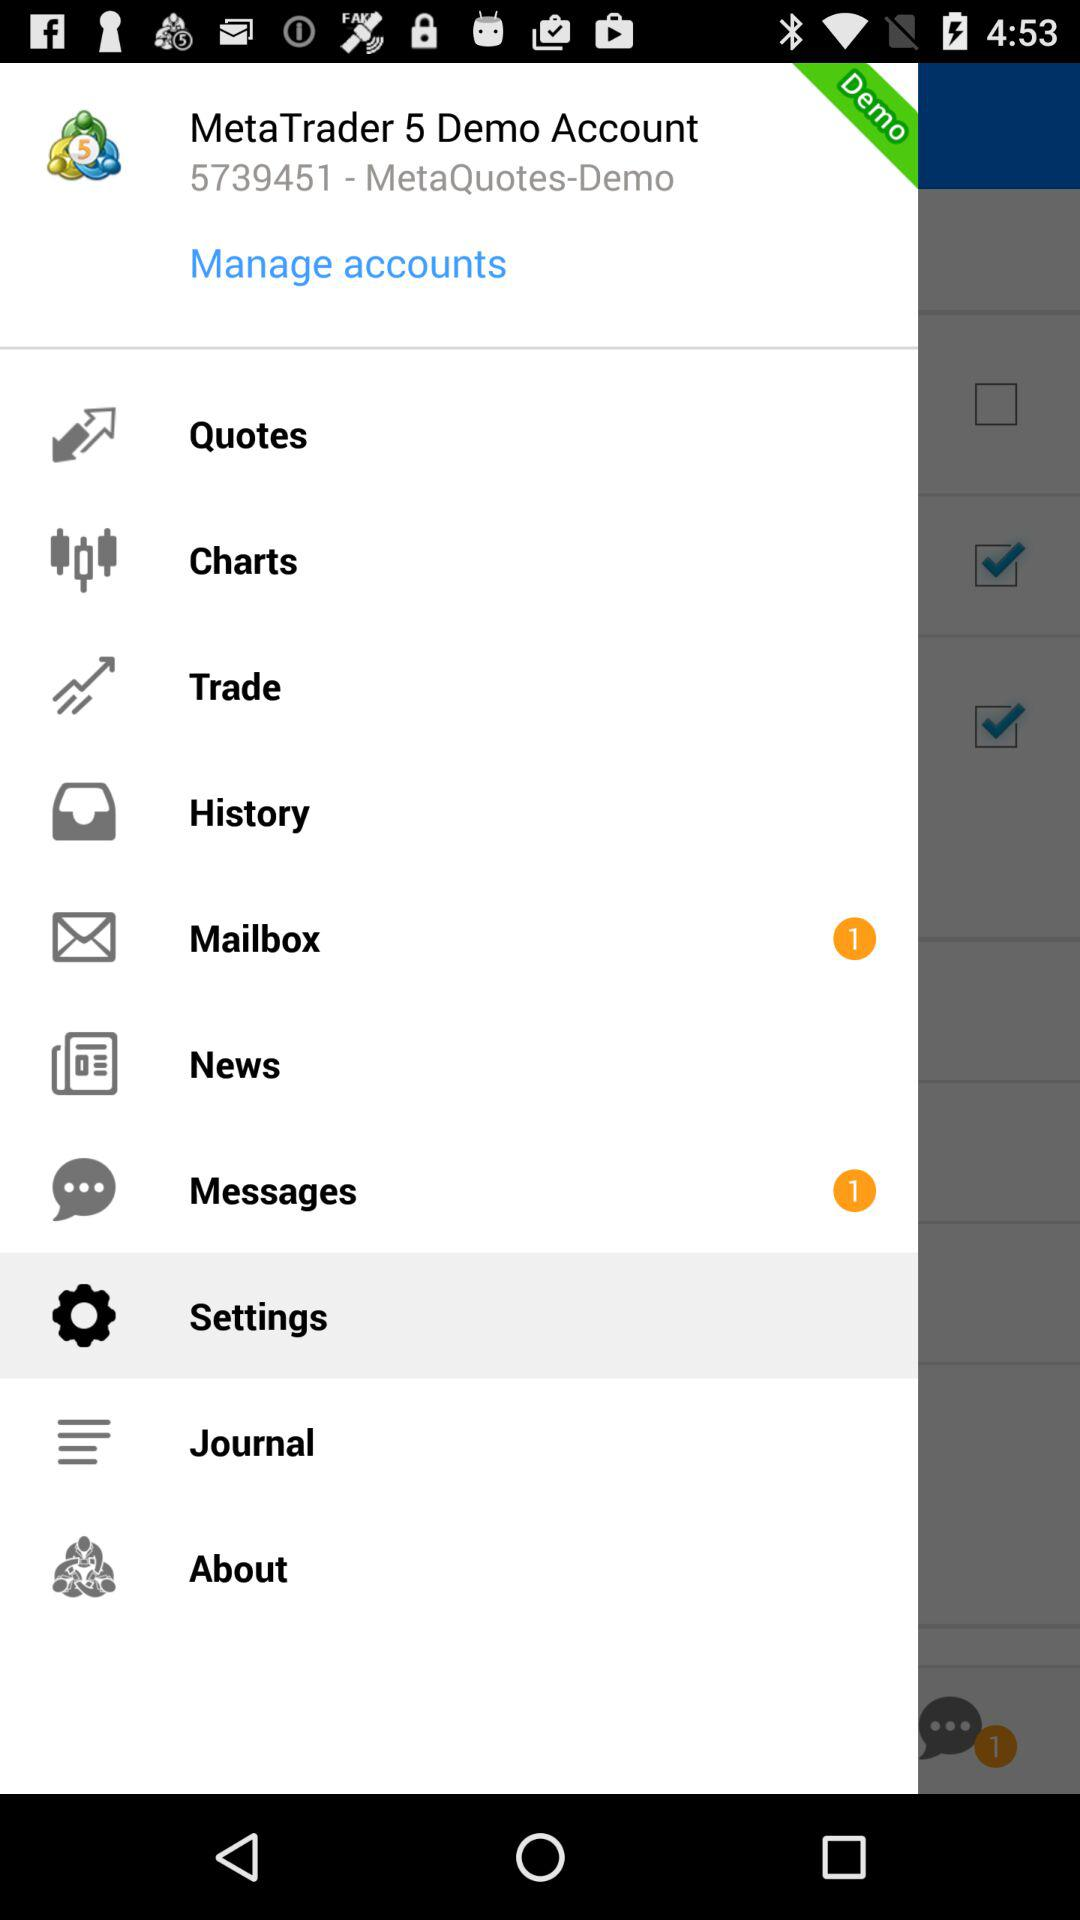How many new messages are there? There is 1 new message. 